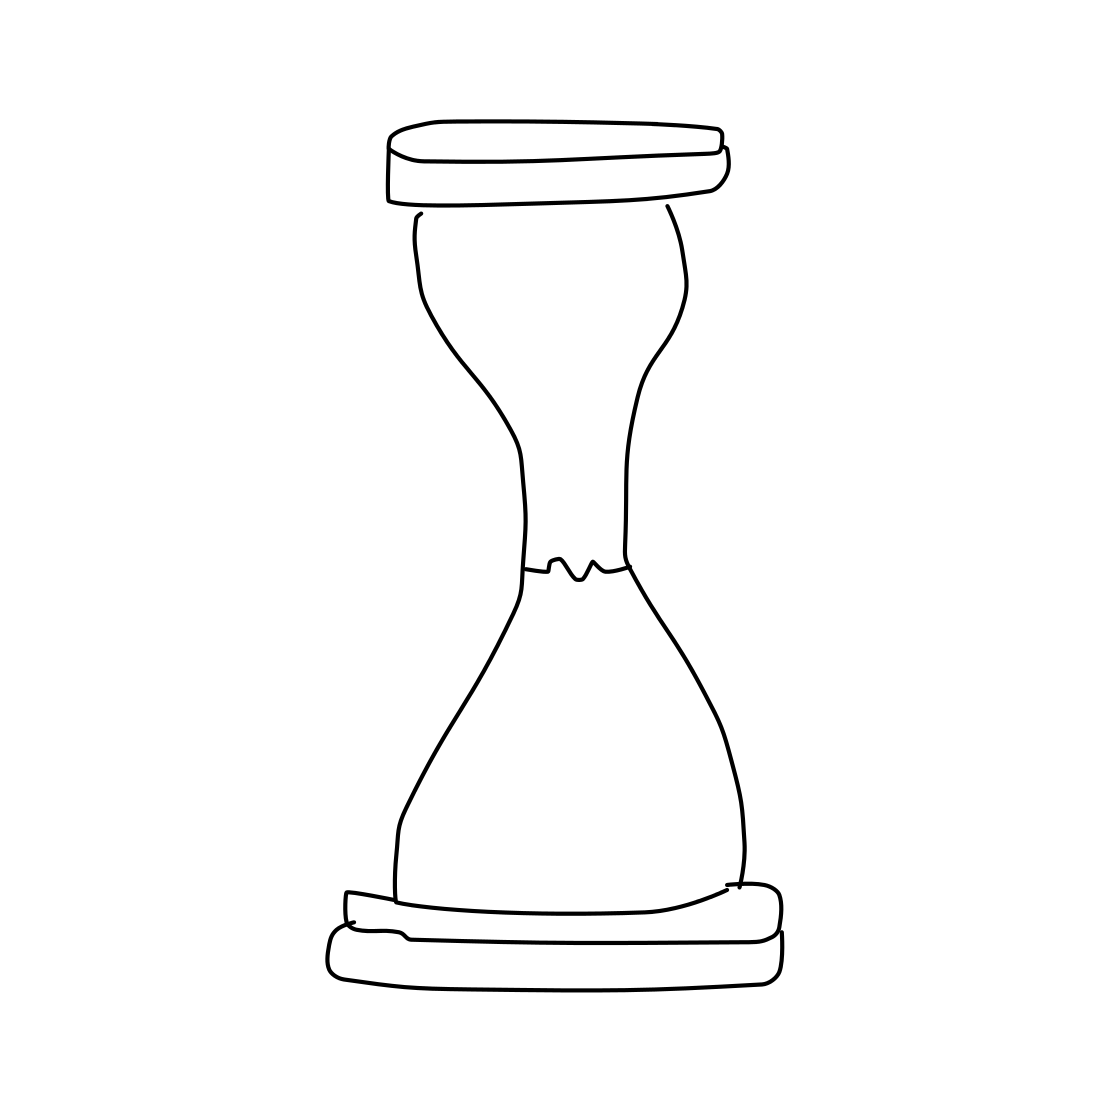Is there a sketchy hourglass in the picture? Yes 